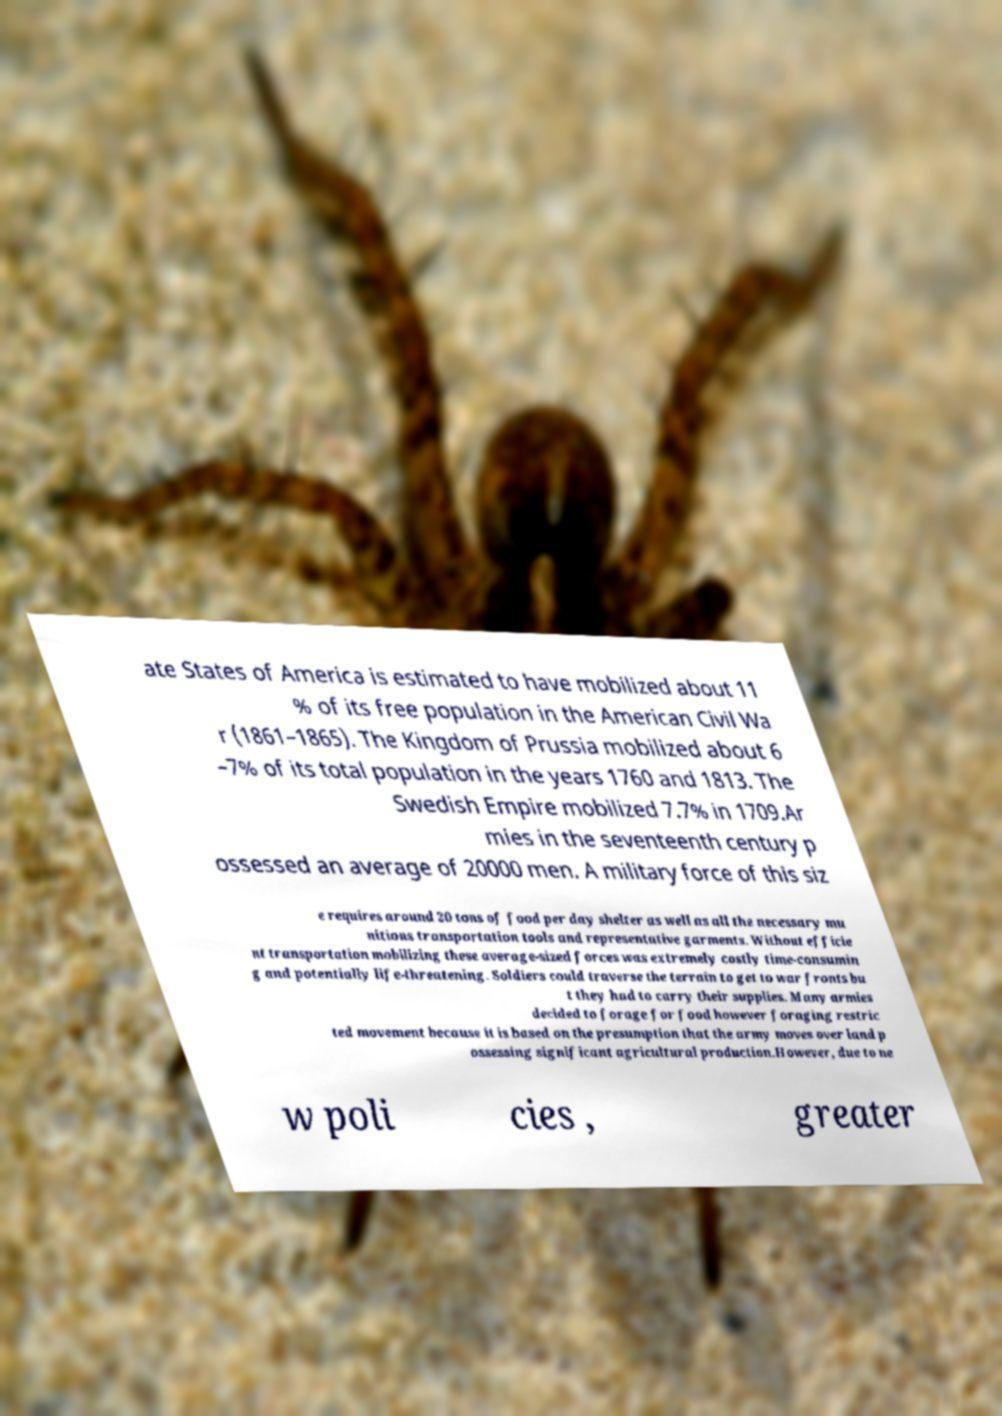Can you accurately transcribe the text from the provided image for me? ate States of America is estimated to have mobilized about 11 % of its free population in the American Civil Wa r (1861–1865). The Kingdom of Prussia mobilized about 6 –7% of its total population in the years 1760 and 1813. The Swedish Empire mobilized 7.7% in 1709.Ar mies in the seventeenth century p ossessed an average of 20000 men. A military force of this siz e requires around 20 tons of food per day shelter as well as all the necessary mu nitions transportation tools and representative garments. Without efficie nt transportation mobilizing these average-sized forces was extremely costly time-consumin g and potentially life-threatening. Soldiers could traverse the terrain to get to war fronts bu t they had to carry their supplies. Many armies decided to forage for food however foraging restric ted movement because it is based on the presumption that the army moves over land p ossessing significant agricultural production.However, due to ne w poli cies , greater 